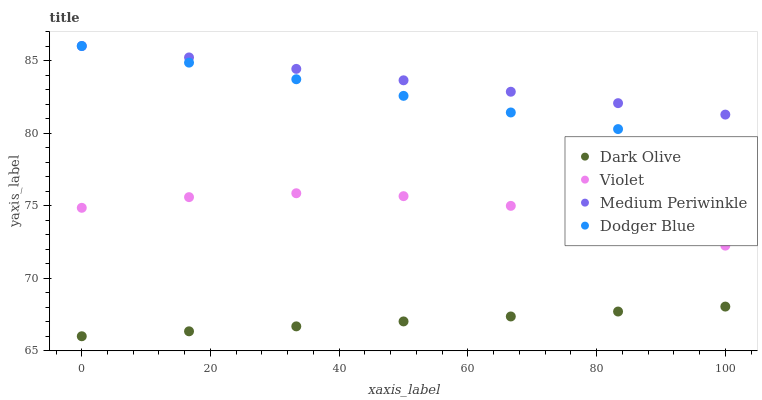Does Dark Olive have the minimum area under the curve?
Answer yes or no. Yes. Does Medium Periwinkle have the maximum area under the curve?
Answer yes or no. Yes. Does Medium Periwinkle have the minimum area under the curve?
Answer yes or no. No. Does Dark Olive have the maximum area under the curve?
Answer yes or no. No. Is Dodger Blue the smoothest?
Answer yes or no. Yes. Is Violet the roughest?
Answer yes or no. Yes. Is Dark Olive the smoothest?
Answer yes or no. No. Is Dark Olive the roughest?
Answer yes or no. No. Does Dark Olive have the lowest value?
Answer yes or no. Yes. Does Medium Periwinkle have the lowest value?
Answer yes or no. No. Does Medium Periwinkle have the highest value?
Answer yes or no. Yes. Does Dark Olive have the highest value?
Answer yes or no. No. Is Dark Olive less than Dodger Blue?
Answer yes or no. Yes. Is Medium Periwinkle greater than Dark Olive?
Answer yes or no. Yes. Does Medium Periwinkle intersect Dodger Blue?
Answer yes or no. Yes. Is Medium Periwinkle less than Dodger Blue?
Answer yes or no. No. Is Medium Periwinkle greater than Dodger Blue?
Answer yes or no. No. Does Dark Olive intersect Dodger Blue?
Answer yes or no. No. 